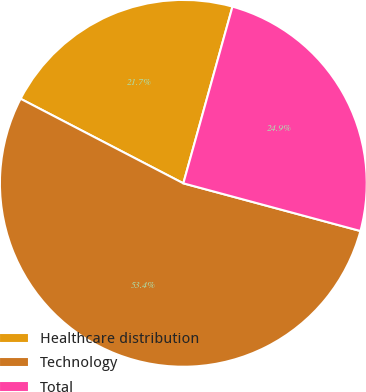Convert chart. <chart><loc_0><loc_0><loc_500><loc_500><pie_chart><fcel>Healthcare distribution<fcel>Technology<fcel>Total<nl><fcel>21.69%<fcel>53.44%<fcel>24.87%<nl></chart> 